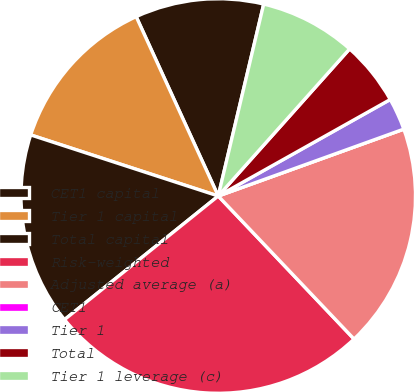Convert chart to OTSL. <chart><loc_0><loc_0><loc_500><loc_500><pie_chart><fcel>CET1 capital<fcel>Tier 1 capital<fcel>Total capital<fcel>Risk-weighted<fcel>Adjusted average (a)<fcel>CET1<fcel>Tier 1<fcel>Total<fcel>Tier 1 leverage (c)<nl><fcel>10.53%<fcel>13.16%<fcel>15.79%<fcel>26.31%<fcel>18.42%<fcel>0.0%<fcel>2.63%<fcel>5.26%<fcel>7.9%<nl></chart> 